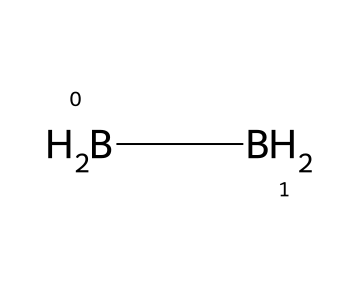What is the chemical name of this compound? The SMILES representation corresponds to diborane, which is identified by the presence of two boron atoms and four hydrogen atoms.
Answer: diborane How many boron atoms are in the compound? The SMILES structure indicates there are two boron atoms connected in the compound.
Answer: 2 How many hydrogen atoms are present in the molecule? The SMILES notation shows that there are four hydrogen atoms bound to the two boron atoms in the structure of diborane.
Answer: 4 What type of bonding occurs between the boron and hydrogen atoms? In diborane, there are two types of bonds: traditional covalent bonds between boron and hydrogen atoms, and also three-center two-electron bonds involving hydrogen atoms.
Answer: covalent Does diborane have a stable or unstable structure? Diborane is generally considered unstable due to its highly reactive nature and the presence of unusual bonding arrangements.
Answer: unstable What is a common application of diborane? Diborane is commonly used as a rocket fuel due to its high energy content and specific impulse properties.
Answer: rocket fuel 